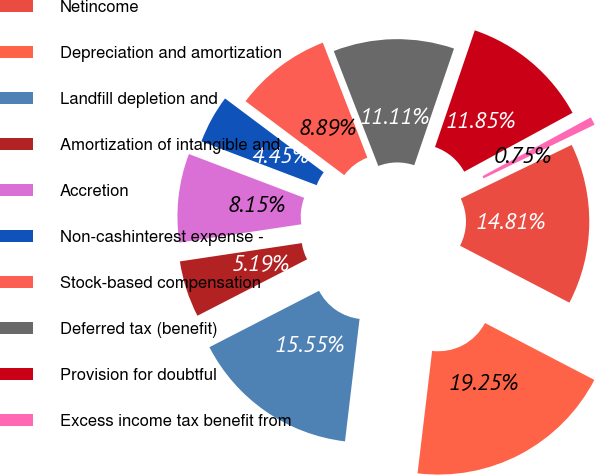Convert chart to OTSL. <chart><loc_0><loc_0><loc_500><loc_500><pie_chart><fcel>Netincome<fcel>Depreciation and amortization<fcel>Landfill depletion and<fcel>Amortization of intangible and<fcel>Accretion<fcel>Non-cashinterest expense -<fcel>Stock-based compensation<fcel>Deferred tax (benefit)<fcel>Provision for doubtful<fcel>Excess income tax benefit from<nl><fcel>14.81%<fcel>19.25%<fcel>15.55%<fcel>5.19%<fcel>8.15%<fcel>4.45%<fcel>8.89%<fcel>11.11%<fcel>11.85%<fcel>0.75%<nl></chart> 